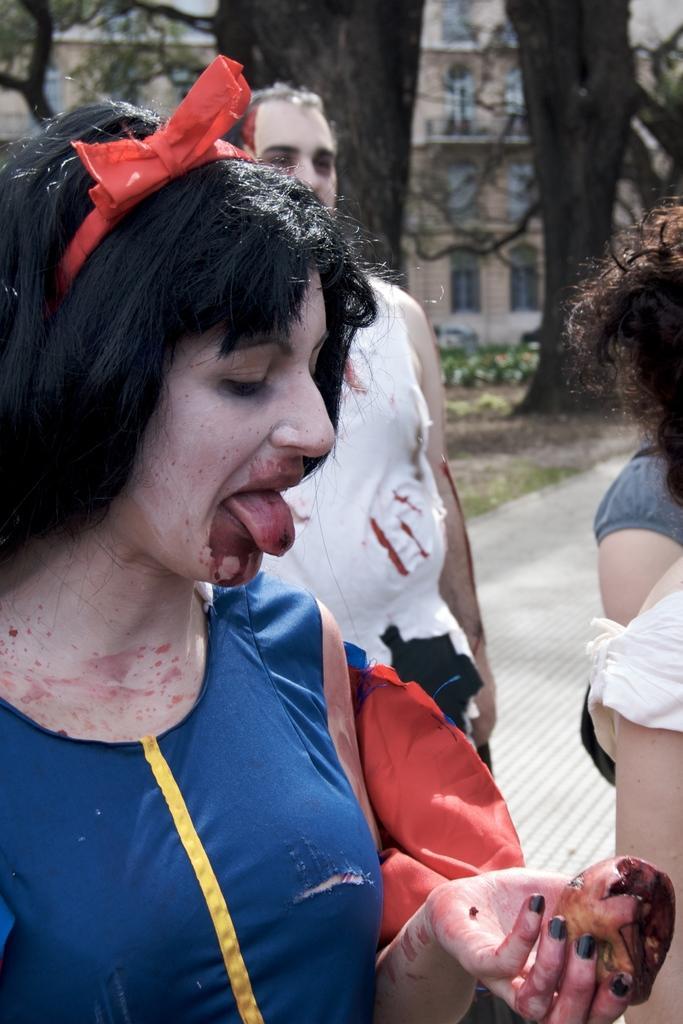Can you describe this image briefly? In the image few people are standing. Behind them there are some trees and buildings and grass. 